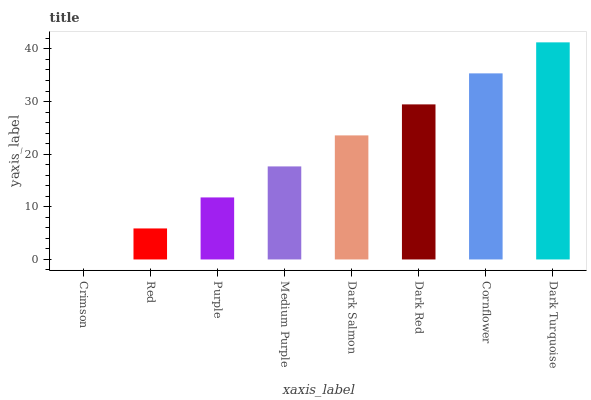Is Crimson the minimum?
Answer yes or no. Yes. Is Dark Turquoise the maximum?
Answer yes or no. Yes. Is Red the minimum?
Answer yes or no. No. Is Red the maximum?
Answer yes or no. No. Is Red greater than Crimson?
Answer yes or no. Yes. Is Crimson less than Red?
Answer yes or no. Yes. Is Crimson greater than Red?
Answer yes or no. No. Is Red less than Crimson?
Answer yes or no. No. Is Dark Salmon the high median?
Answer yes or no. Yes. Is Medium Purple the low median?
Answer yes or no. Yes. Is Red the high median?
Answer yes or no. No. Is Dark Red the low median?
Answer yes or no. No. 